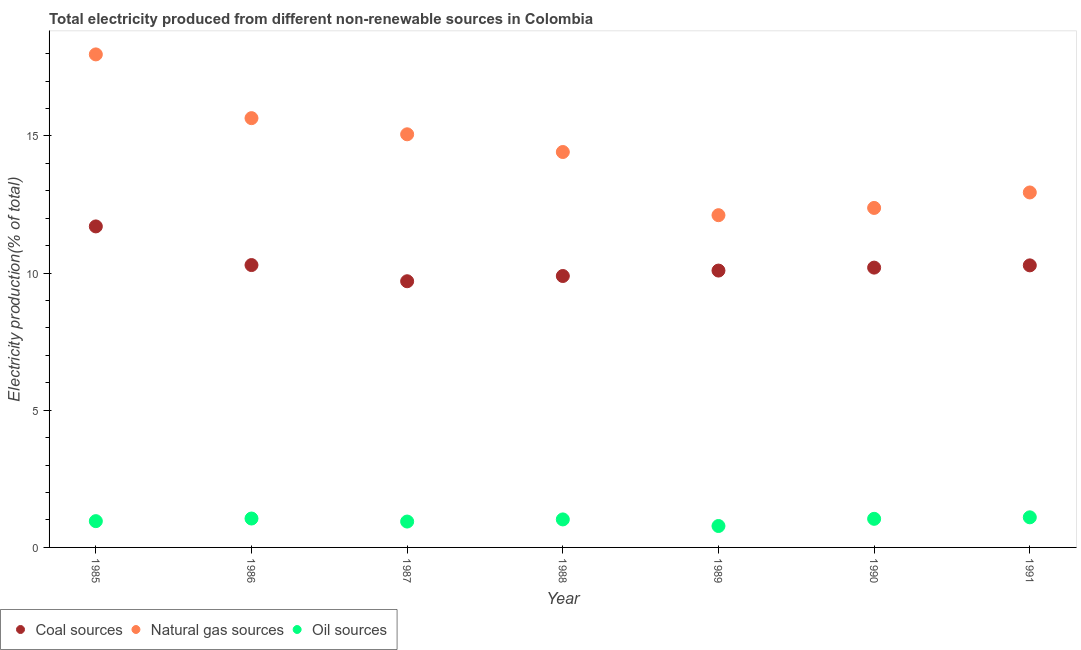Is the number of dotlines equal to the number of legend labels?
Offer a very short reply. Yes. What is the percentage of electricity produced by oil sources in 1988?
Make the answer very short. 1.02. Across all years, what is the maximum percentage of electricity produced by coal?
Ensure brevity in your answer.  11.7. Across all years, what is the minimum percentage of electricity produced by natural gas?
Your answer should be compact. 12.11. What is the total percentage of electricity produced by coal in the graph?
Your response must be concise. 72.16. What is the difference between the percentage of electricity produced by oil sources in 1986 and that in 1990?
Provide a succinct answer. 0.01. What is the difference between the percentage of electricity produced by oil sources in 1985 and the percentage of electricity produced by coal in 1990?
Keep it short and to the point. -9.24. What is the average percentage of electricity produced by natural gas per year?
Keep it short and to the point. 14.36. In the year 1986, what is the difference between the percentage of electricity produced by coal and percentage of electricity produced by oil sources?
Ensure brevity in your answer.  9.24. In how many years, is the percentage of electricity produced by natural gas greater than 13 %?
Your answer should be very brief. 4. What is the ratio of the percentage of electricity produced by oil sources in 1987 to that in 1991?
Ensure brevity in your answer.  0.86. What is the difference between the highest and the second highest percentage of electricity produced by coal?
Your answer should be very brief. 1.41. What is the difference between the highest and the lowest percentage of electricity produced by oil sources?
Your response must be concise. 0.32. Is it the case that in every year, the sum of the percentage of electricity produced by coal and percentage of electricity produced by natural gas is greater than the percentage of electricity produced by oil sources?
Keep it short and to the point. Yes. Does the percentage of electricity produced by natural gas monotonically increase over the years?
Keep it short and to the point. No. Is the percentage of electricity produced by oil sources strictly less than the percentage of electricity produced by natural gas over the years?
Provide a succinct answer. Yes. How many dotlines are there?
Your answer should be compact. 3. What is the difference between two consecutive major ticks on the Y-axis?
Offer a very short reply. 5. Are the values on the major ticks of Y-axis written in scientific E-notation?
Ensure brevity in your answer.  No. Does the graph contain grids?
Offer a very short reply. No. Where does the legend appear in the graph?
Provide a short and direct response. Bottom left. How are the legend labels stacked?
Provide a short and direct response. Horizontal. What is the title of the graph?
Your answer should be compact. Total electricity produced from different non-renewable sources in Colombia. Does "Tertiary" appear as one of the legend labels in the graph?
Offer a terse response. No. What is the label or title of the Y-axis?
Ensure brevity in your answer.  Electricity production(% of total). What is the Electricity production(% of total) in Coal sources in 1985?
Offer a very short reply. 11.7. What is the Electricity production(% of total) in Natural gas sources in 1985?
Make the answer very short. 17.97. What is the Electricity production(% of total) of Oil sources in 1985?
Offer a terse response. 0.96. What is the Electricity production(% of total) of Coal sources in 1986?
Ensure brevity in your answer.  10.29. What is the Electricity production(% of total) in Natural gas sources in 1986?
Keep it short and to the point. 15.65. What is the Electricity production(% of total) of Oil sources in 1986?
Provide a succinct answer. 1.05. What is the Electricity production(% of total) in Coal sources in 1987?
Give a very brief answer. 9.7. What is the Electricity production(% of total) in Natural gas sources in 1987?
Give a very brief answer. 15.06. What is the Electricity production(% of total) of Oil sources in 1987?
Ensure brevity in your answer.  0.94. What is the Electricity production(% of total) in Coal sources in 1988?
Make the answer very short. 9.89. What is the Electricity production(% of total) in Natural gas sources in 1988?
Provide a short and direct response. 14.41. What is the Electricity production(% of total) of Oil sources in 1988?
Your answer should be compact. 1.02. What is the Electricity production(% of total) of Coal sources in 1989?
Keep it short and to the point. 10.09. What is the Electricity production(% of total) of Natural gas sources in 1989?
Make the answer very short. 12.11. What is the Electricity production(% of total) in Oil sources in 1989?
Provide a short and direct response. 0.78. What is the Electricity production(% of total) of Coal sources in 1990?
Offer a terse response. 10.2. What is the Electricity production(% of total) of Natural gas sources in 1990?
Your response must be concise. 12.37. What is the Electricity production(% of total) in Oil sources in 1990?
Offer a very short reply. 1.04. What is the Electricity production(% of total) of Coal sources in 1991?
Keep it short and to the point. 10.28. What is the Electricity production(% of total) in Natural gas sources in 1991?
Ensure brevity in your answer.  12.94. What is the Electricity production(% of total) of Oil sources in 1991?
Keep it short and to the point. 1.1. Across all years, what is the maximum Electricity production(% of total) of Coal sources?
Your response must be concise. 11.7. Across all years, what is the maximum Electricity production(% of total) in Natural gas sources?
Provide a succinct answer. 17.97. Across all years, what is the maximum Electricity production(% of total) of Oil sources?
Provide a succinct answer. 1.1. Across all years, what is the minimum Electricity production(% of total) in Coal sources?
Your answer should be compact. 9.7. Across all years, what is the minimum Electricity production(% of total) of Natural gas sources?
Offer a very short reply. 12.11. Across all years, what is the minimum Electricity production(% of total) of Oil sources?
Your answer should be compact. 0.78. What is the total Electricity production(% of total) in Coal sources in the graph?
Your response must be concise. 72.16. What is the total Electricity production(% of total) of Natural gas sources in the graph?
Your answer should be very brief. 100.51. What is the total Electricity production(% of total) of Oil sources in the graph?
Ensure brevity in your answer.  6.9. What is the difference between the Electricity production(% of total) in Coal sources in 1985 and that in 1986?
Provide a short and direct response. 1.41. What is the difference between the Electricity production(% of total) in Natural gas sources in 1985 and that in 1986?
Offer a terse response. 2.32. What is the difference between the Electricity production(% of total) of Oil sources in 1985 and that in 1986?
Keep it short and to the point. -0.1. What is the difference between the Electricity production(% of total) in Coal sources in 1985 and that in 1987?
Offer a terse response. 2. What is the difference between the Electricity production(% of total) in Natural gas sources in 1985 and that in 1987?
Your answer should be compact. 2.91. What is the difference between the Electricity production(% of total) of Oil sources in 1985 and that in 1987?
Your answer should be compact. 0.01. What is the difference between the Electricity production(% of total) in Coal sources in 1985 and that in 1988?
Provide a succinct answer. 1.81. What is the difference between the Electricity production(% of total) of Natural gas sources in 1985 and that in 1988?
Keep it short and to the point. 3.56. What is the difference between the Electricity production(% of total) in Oil sources in 1985 and that in 1988?
Ensure brevity in your answer.  -0.06. What is the difference between the Electricity production(% of total) in Coal sources in 1985 and that in 1989?
Your answer should be very brief. 1.61. What is the difference between the Electricity production(% of total) in Natural gas sources in 1985 and that in 1989?
Provide a short and direct response. 5.86. What is the difference between the Electricity production(% of total) in Oil sources in 1985 and that in 1989?
Make the answer very short. 0.18. What is the difference between the Electricity production(% of total) in Coal sources in 1985 and that in 1990?
Make the answer very short. 1.5. What is the difference between the Electricity production(% of total) of Natural gas sources in 1985 and that in 1990?
Keep it short and to the point. 5.6. What is the difference between the Electricity production(% of total) of Oil sources in 1985 and that in 1990?
Your answer should be compact. -0.08. What is the difference between the Electricity production(% of total) of Coal sources in 1985 and that in 1991?
Offer a terse response. 1.42. What is the difference between the Electricity production(% of total) of Natural gas sources in 1985 and that in 1991?
Keep it short and to the point. 5.03. What is the difference between the Electricity production(% of total) in Oil sources in 1985 and that in 1991?
Make the answer very short. -0.14. What is the difference between the Electricity production(% of total) of Coal sources in 1986 and that in 1987?
Your answer should be compact. 0.59. What is the difference between the Electricity production(% of total) of Natural gas sources in 1986 and that in 1987?
Give a very brief answer. 0.59. What is the difference between the Electricity production(% of total) of Oil sources in 1986 and that in 1987?
Your response must be concise. 0.11. What is the difference between the Electricity production(% of total) in Coal sources in 1986 and that in 1988?
Give a very brief answer. 0.4. What is the difference between the Electricity production(% of total) in Natural gas sources in 1986 and that in 1988?
Offer a terse response. 1.23. What is the difference between the Electricity production(% of total) in Oil sources in 1986 and that in 1988?
Provide a short and direct response. 0.03. What is the difference between the Electricity production(% of total) in Coal sources in 1986 and that in 1989?
Offer a terse response. 0.2. What is the difference between the Electricity production(% of total) in Natural gas sources in 1986 and that in 1989?
Ensure brevity in your answer.  3.54. What is the difference between the Electricity production(% of total) of Oil sources in 1986 and that in 1989?
Give a very brief answer. 0.27. What is the difference between the Electricity production(% of total) of Coal sources in 1986 and that in 1990?
Your answer should be compact. 0.09. What is the difference between the Electricity production(% of total) of Natural gas sources in 1986 and that in 1990?
Your response must be concise. 3.27. What is the difference between the Electricity production(% of total) of Oil sources in 1986 and that in 1990?
Ensure brevity in your answer.  0.01. What is the difference between the Electricity production(% of total) in Coal sources in 1986 and that in 1991?
Your answer should be very brief. 0.01. What is the difference between the Electricity production(% of total) of Natural gas sources in 1986 and that in 1991?
Your response must be concise. 2.71. What is the difference between the Electricity production(% of total) in Oil sources in 1986 and that in 1991?
Ensure brevity in your answer.  -0.04. What is the difference between the Electricity production(% of total) in Coal sources in 1987 and that in 1988?
Your answer should be very brief. -0.19. What is the difference between the Electricity production(% of total) of Natural gas sources in 1987 and that in 1988?
Provide a succinct answer. 0.65. What is the difference between the Electricity production(% of total) in Oil sources in 1987 and that in 1988?
Make the answer very short. -0.08. What is the difference between the Electricity production(% of total) in Coal sources in 1987 and that in 1989?
Give a very brief answer. -0.39. What is the difference between the Electricity production(% of total) in Natural gas sources in 1987 and that in 1989?
Your answer should be compact. 2.95. What is the difference between the Electricity production(% of total) of Oil sources in 1987 and that in 1989?
Keep it short and to the point. 0.16. What is the difference between the Electricity production(% of total) of Coal sources in 1987 and that in 1990?
Offer a terse response. -0.5. What is the difference between the Electricity production(% of total) in Natural gas sources in 1987 and that in 1990?
Offer a very short reply. 2.68. What is the difference between the Electricity production(% of total) of Oil sources in 1987 and that in 1990?
Your answer should be compact. -0.1. What is the difference between the Electricity production(% of total) of Coal sources in 1987 and that in 1991?
Keep it short and to the point. -0.58. What is the difference between the Electricity production(% of total) of Natural gas sources in 1987 and that in 1991?
Provide a short and direct response. 2.12. What is the difference between the Electricity production(% of total) in Oil sources in 1987 and that in 1991?
Your answer should be very brief. -0.15. What is the difference between the Electricity production(% of total) in Coal sources in 1988 and that in 1989?
Offer a terse response. -0.2. What is the difference between the Electricity production(% of total) of Natural gas sources in 1988 and that in 1989?
Ensure brevity in your answer.  2.3. What is the difference between the Electricity production(% of total) of Oil sources in 1988 and that in 1989?
Offer a terse response. 0.24. What is the difference between the Electricity production(% of total) of Coal sources in 1988 and that in 1990?
Offer a terse response. -0.31. What is the difference between the Electricity production(% of total) of Natural gas sources in 1988 and that in 1990?
Your answer should be compact. 2.04. What is the difference between the Electricity production(% of total) of Oil sources in 1988 and that in 1990?
Your answer should be very brief. -0.02. What is the difference between the Electricity production(% of total) in Coal sources in 1988 and that in 1991?
Your response must be concise. -0.39. What is the difference between the Electricity production(% of total) in Natural gas sources in 1988 and that in 1991?
Offer a very short reply. 1.47. What is the difference between the Electricity production(% of total) in Oil sources in 1988 and that in 1991?
Your answer should be compact. -0.08. What is the difference between the Electricity production(% of total) in Coal sources in 1989 and that in 1990?
Ensure brevity in your answer.  -0.11. What is the difference between the Electricity production(% of total) in Natural gas sources in 1989 and that in 1990?
Your answer should be very brief. -0.26. What is the difference between the Electricity production(% of total) in Oil sources in 1989 and that in 1990?
Your answer should be very brief. -0.26. What is the difference between the Electricity production(% of total) in Coal sources in 1989 and that in 1991?
Keep it short and to the point. -0.19. What is the difference between the Electricity production(% of total) of Natural gas sources in 1989 and that in 1991?
Keep it short and to the point. -0.83. What is the difference between the Electricity production(% of total) in Oil sources in 1989 and that in 1991?
Your answer should be compact. -0.32. What is the difference between the Electricity production(% of total) in Coal sources in 1990 and that in 1991?
Your answer should be very brief. -0.08. What is the difference between the Electricity production(% of total) of Natural gas sources in 1990 and that in 1991?
Make the answer very short. -0.56. What is the difference between the Electricity production(% of total) in Oil sources in 1990 and that in 1991?
Ensure brevity in your answer.  -0.06. What is the difference between the Electricity production(% of total) of Coal sources in 1985 and the Electricity production(% of total) of Natural gas sources in 1986?
Your answer should be very brief. -3.95. What is the difference between the Electricity production(% of total) in Coal sources in 1985 and the Electricity production(% of total) in Oil sources in 1986?
Provide a succinct answer. 10.65. What is the difference between the Electricity production(% of total) of Natural gas sources in 1985 and the Electricity production(% of total) of Oil sources in 1986?
Provide a succinct answer. 16.92. What is the difference between the Electricity production(% of total) in Coal sources in 1985 and the Electricity production(% of total) in Natural gas sources in 1987?
Offer a terse response. -3.36. What is the difference between the Electricity production(% of total) of Coal sources in 1985 and the Electricity production(% of total) of Oil sources in 1987?
Provide a short and direct response. 10.76. What is the difference between the Electricity production(% of total) in Natural gas sources in 1985 and the Electricity production(% of total) in Oil sources in 1987?
Keep it short and to the point. 17.03. What is the difference between the Electricity production(% of total) in Coal sources in 1985 and the Electricity production(% of total) in Natural gas sources in 1988?
Your answer should be compact. -2.71. What is the difference between the Electricity production(% of total) of Coal sources in 1985 and the Electricity production(% of total) of Oil sources in 1988?
Provide a succinct answer. 10.68. What is the difference between the Electricity production(% of total) in Natural gas sources in 1985 and the Electricity production(% of total) in Oil sources in 1988?
Ensure brevity in your answer.  16.95. What is the difference between the Electricity production(% of total) in Coal sources in 1985 and the Electricity production(% of total) in Natural gas sources in 1989?
Provide a succinct answer. -0.41. What is the difference between the Electricity production(% of total) in Coal sources in 1985 and the Electricity production(% of total) in Oil sources in 1989?
Your answer should be compact. 10.92. What is the difference between the Electricity production(% of total) in Natural gas sources in 1985 and the Electricity production(% of total) in Oil sources in 1989?
Offer a very short reply. 17.19. What is the difference between the Electricity production(% of total) of Coal sources in 1985 and the Electricity production(% of total) of Natural gas sources in 1990?
Give a very brief answer. -0.67. What is the difference between the Electricity production(% of total) in Coal sources in 1985 and the Electricity production(% of total) in Oil sources in 1990?
Offer a terse response. 10.66. What is the difference between the Electricity production(% of total) in Natural gas sources in 1985 and the Electricity production(% of total) in Oil sources in 1990?
Provide a succinct answer. 16.93. What is the difference between the Electricity production(% of total) of Coal sources in 1985 and the Electricity production(% of total) of Natural gas sources in 1991?
Offer a terse response. -1.24. What is the difference between the Electricity production(% of total) in Coal sources in 1985 and the Electricity production(% of total) in Oil sources in 1991?
Give a very brief answer. 10.6. What is the difference between the Electricity production(% of total) of Natural gas sources in 1985 and the Electricity production(% of total) of Oil sources in 1991?
Your answer should be very brief. 16.87. What is the difference between the Electricity production(% of total) of Coal sources in 1986 and the Electricity production(% of total) of Natural gas sources in 1987?
Your answer should be very brief. -4.77. What is the difference between the Electricity production(% of total) in Coal sources in 1986 and the Electricity production(% of total) in Oil sources in 1987?
Your answer should be very brief. 9.35. What is the difference between the Electricity production(% of total) in Natural gas sources in 1986 and the Electricity production(% of total) in Oil sources in 1987?
Provide a succinct answer. 14.7. What is the difference between the Electricity production(% of total) in Coal sources in 1986 and the Electricity production(% of total) in Natural gas sources in 1988?
Offer a terse response. -4.12. What is the difference between the Electricity production(% of total) of Coal sources in 1986 and the Electricity production(% of total) of Oil sources in 1988?
Make the answer very short. 9.27. What is the difference between the Electricity production(% of total) of Natural gas sources in 1986 and the Electricity production(% of total) of Oil sources in 1988?
Your response must be concise. 14.63. What is the difference between the Electricity production(% of total) in Coal sources in 1986 and the Electricity production(% of total) in Natural gas sources in 1989?
Provide a short and direct response. -1.82. What is the difference between the Electricity production(% of total) in Coal sources in 1986 and the Electricity production(% of total) in Oil sources in 1989?
Give a very brief answer. 9.51. What is the difference between the Electricity production(% of total) in Natural gas sources in 1986 and the Electricity production(% of total) in Oil sources in 1989?
Provide a succinct answer. 14.87. What is the difference between the Electricity production(% of total) in Coal sources in 1986 and the Electricity production(% of total) in Natural gas sources in 1990?
Offer a very short reply. -2.08. What is the difference between the Electricity production(% of total) of Coal sources in 1986 and the Electricity production(% of total) of Oil sources in 1990?
Give a very brief answer. 9.25. What is the difference between the Electricity production(% of total) in Natural gas sources in 1986 and the Electricity production(% of total) in Oil sources in 1990?
Provide a short and direct response. 14.6. What is the difference between the Electricity production(% of total) in Coal sources in 1986 and the Electricity production(% of total) in Natural gas sources in 1991?
Keep it short and to the point. -2.65. What is the difference between the Electricity production(% of total) of Coal sources in 1986 and the Electricity production(% of total) of Oil sources in 1991?
Offer a very short reply. 9.19. What is the difference between the Electricity production(% of total) in Natural gas sources in 1986 and the Electricity production(% of total) in Oil sources in 1991?
Make the answer very short. 14.55. What is the difference between the Electricity production(% of total) in Coal sources in 1987 and the Electricity production(% of total) in Natural gas sources in 1988?
Ensure brevity in your answer.  -4.71. What is the difference between the Electricity production(% of total) of Coal sources in 1987 and the Electricity production(% of total) of Oil sources in 1988?
Offer a very short reply. 8.68. What is the difference between the Electricity production(% of total) in Natural gas sources in 1987 and the Electricity production(% of total) in Oil sources in 1988?
Offer a very short reply. 14.04. What is the difference between the Electricity production(% of total) in Coal sources in 1987 and the Electricity production(% of total) in Natural gas sources in 1989?
Your answer should be very brief. -2.41. What is the difference between the Electricity production(% of total) of Coal sources in 1987 and the Electricity production(% of total) of Oil sources in 1989?
Provide a succinct answer. 8.92. What is the difference between the Electricity production(% of total) of Natural gas sources in 1987 and the Electricity production(% of total) of Oil sources in 1989?
Provide a short and direct response. 14.28. What is the difference between the Electricity production(% of total) in Coal sources in 1987 and the Electricity production(% of total) in Natural gas sources in 1990?
Keep it short and to the point. -2.67. What is the difference between the Electricity production(% of total) in Coal sources in 1987 and the Electricity production(% of total) in Oil sources in 1990?
Your answer should be compact. 8.66. What is the difference between the Electricity production(% of total) of Natural gas sources in 1987 and the Electricity production(% of total) of Oil sources in 1990?
Your response must be concise. 14.02. What is the difference between the Electricity production(% of total) of Coal sources in 1987 and the Electricity production(% of total) of Natural gas sources in 1991?
Provide a succinct answer. -3.24. What is the difference between the Electricity production(% of total) in Coal sources in 1987 and the Electricity production(% of total) in Oil sources in 1991?
Ensure brevity in your answer.  8.6. What is the difference between the Electricity production(% of total) in Natural gas sources in 1987 and the Electricity production(% of total) in Oil sources in 1991?
Offer a terse response. 13.96. What is the difference between the Electricity production(% of total) of Coal sources in 1988 and the Electricity production(% of total) of Natural gas sources in 1989?
Your answer should be very brief. -2.22. What is the difference between the Electricity production(% of total) of Coal sources in 1988 and the Electricity production(% of total) of Oil sources in 1989?
Keep it short and to the point. 9.11. What is the difference between the Electricity production(% of total) of Natural gas sources in 1988 and the Electricity production(% of total) of Oil sources in 1989?
Keep it short and to the point. 13.63. What is the difference between the Electricity production(% of total) in Coal sources in 1988 and the Electricity production(% of total) in Natural gas sources in 1990?
Your answer should be compact. -2.48. What is the difference between the Electricity production(% of total) of Coal sources in 1988 and the Electricity production(% of total) of Oil sources in 1990?
Your answer should be compact. 8.85. What is the difference between the Electricity production(% of total) in Natural gas sources in 1988 and the Electricity production(% of total) in Oil sources in 1990?
Your answer should be very brief. 13.37. What is the difference between the Electricity production(% of total) of Coal sources in 1988 and the Electricity production(% of total) of Natural gas sources in 1991?
Give a very brief answer. -3.05. What is the difference between the Electricity production(% of total) in Coal sources in 1988 and the Electricity production(% of total) in Oil sources in 1991?
Provide a succinct answer. 8.8. What is the difference between the Electricity production(% of total) of Natural gas sources in 1988 and the Electricity production(% of total) of Oil sources in 1991?
Keep it short and to the point. 13.32. What is the difference between the Electricity production(% of total) in Coal sources in 1989 and the Electricity production(% of total) in Natural gas sources in 1990?
Ensure brevity in your answer.  -2.28. What is the difference between the Electricity production(% of total) of Coal sources in 1989 and the Electricity production(% of total) of Oil sources in 1990?
Your answer should be compact. 9.05. What is the difference between the Electricity production(% of total) of Natural gas sources in 1989 and the Electricity production(% of total) of Oil sources in 1990?
Ensure brevity in your answer.  11.07. What is the difference between the Electricity production(% of total) in Coal sources in 1989 and the Electricity production(% of total) in Natural gas sources in 1991?
Your response must be concise. -2.85. What is the difference between the Electricity production(% of total) of Coal sources in 1989 and the Electricity production(% of total) of Oil sources in 1991?
Your answer should be very brief. 8.99. What is the difference between the Electricity production(% of total) of Natural gas sources in 1989 and the Electricity production(% of total) of Oil sources in 1991?
Give a very brief answer. 11.01. What is the difference between the Electricity production(% of total) of Coal sources in 1990 and the Electricity production(% of total) of Natural gas sources in 1991?
Provide a short and direct response. -2.74. What is the difference between the Electricity production(% of total) in Coal sources in 1990 and the Electricity production(% of total) in Oil sources in 1991?
Offer a terse response. 9.1. What is the difference between the Electricity production(% of total) in Natural gas sources in 1990 and the Electricity production(% of total) in Oil sources in 1991?
Make the answer very short. 11.28. What is the average Electricity production(% of total) of Coal sources per year?
Your answer should be compact. 10.31. What is the average Electricity production(% of total) in Natural gas sources per year?
Your answer should be very brief. 14.36. What is the average Electricity production(% of total) of Oil sources per year?
Provide a succinct answer. 0.99. In the year 1985, what is the difference between the Electricity production(% of total) of Coal sources and Electricity production(% of total) of Natural gas sources?
Keep it short and to the point. -6.27. In the year 1985, what is the difference between the Electricity production(% of total) of Coal sources and Electricity production(% of total) of Oil sources?
Your response must be concise. 10.74. In the year 1985, what is the difference between the Electricity production(% of total) of Natural gas sources and Electricity production(% of total) of Oil sources?
Provide a short and direct response. 17.01. In the year 1986, what is the difference between the Electricity production(% of total) in Coal sources and Electricity production(% of total) in Natural gas sources?
Provide a short and direct response. -5.36. In the year 1986, what is the difference between the Electricity production(% of total) in Coal sources and Electricity production(% of total) in Oil sources?
Keep it short and to the point. 9.24. In the year 1986, what is the difference between the Electricity production(% of total) in Natural gas sources and Electricity production(% of total) in Oil sources?
Offer a terse response. 14.59. In the year 1987, what is the difference between the Electricity production(% of total) of Coal sources and Electricity production(% of total) of Natural gas sources?
Keep it short and to the point. -5.36. In the year 1987, what is the difference between the Electricity production(% of total) of Coal sources and Electricity production(% of total) of Oil sources?
Provide a short and direct response. 8.76. In the year 1987, what is the difference between the Electricity production(% of total) of Natural gas sources and Electricity production(% of total) of Oil sources?
Make the answer very short. 14.12. In the year 1988, what is the difference between the Electricity production(% of total) of Coal sources and Electricity production(% of total) of Natural gas sources?
Your response must be concise. -4.52. In the year 1988, what is the difference between the Electricity production(% of total) in Coal sources and Electricity production(% of total) in Oil sources?
Your answer should be very brief. 8.87. In the year 1988, what is the difference between the Electricity production(% of total) in Natural gas sources and Electricity production(% of total) in Oil sources?
Your answer should be very brief. 13.39. In the year 1989, what is the difference between the Electricity production(% of total) in Coal sources and Electricity production(% of total) in Natural gas sources?
Make the answer very short. -2.02. In the year 1989, what is the difference between the Electricity production(% of total) of Coal sources and Electricity production(% of total) of Oil sources?
Ensure brevity in your answer.  9.31. In the year 1989, what is the difference between the Electricity production(% of total) of Natural gas sources and Electricity production(% of total) of Oil sources?
Offer a terse response. 11.33. In the year 1990, what is the difference between the Electricity production(% of total) of Coal sources and Electricity production(% of total) of Natural gas sources?
Offer a very short reply. -2.18. In the year 1990, what is the difference between the Electricity production(% of total) of Coal sources and Electricity production(% of total) of Oil sources?
Your answer should be compact. 9.16. In the year 1990, what is the difference between the Electricity production(% of total) in Natural gas sources and Electricity production(% of total) in Oil sources?
Offer a very short reply. 11.33. In the year 1991, what is the difference between the Electricity production(% of total) of Coal sources and Electricity production(% of total) of Natural gas sources?
Offer a terse response. -2.66. In the year 1991, what is the difference between the Electricity production(% of total) of Coal sources and Electricity production(% of total) of Oil sources?
Offer a very short reply. 9.18. In the year 1991, what is the difference between the Electricity production(% of total) of Natural gas sources and Electricity production(% of total) of Oil sources?
Provide a succinct answer. 11.84. What is the ratio of the Electricity production(% of total) of Coal sources in 1985 to that in 1986?
Ensure brevity in your answer.  1.14. What is the ratio of the Electricity production(% of total) of Natural gas sources in 1985 to that in 1986?
Provide a short and direct response. 1.15. What is the ratio of the Electricity production(% of total) of Oil sources in 1985 to that in 1986?
Give a very brief answer. 0.91. What is the ratio of the Electricity production(% of total) in Coal sources in 1985 to that in 1987?
Give a very brief answer. 1.21. What is the ratio of the Electricity production(% of total) of Natural gas sources in 1985 to that in 1987?
Provide a succinct answer. 1.19. What is the ratio of the Electricity production(% of total) in Oil sources in 1985 to that in 1987?
Provide a short and direct response. 1.02. What is the ratio of the Electricity production(% of total) of Coal sources in 1985 to that in 1988?
Provide a short and direct response. 1.18. What is the ratio of the Electricity production(% of total) in Natural gas sources in 1985 to that in 1988?
Provide a succinct answer. 1.25. What is the ratio of the Electricity production(% of total) of Oil sources in 1985 to that in 1988?
Your response must be concise. 0.94. What is the ratio of the Electricity production(% of total) in Coal sources in 1985 to that in 1989?
Provide a short and direct response. 1.16. What is the ratio of the Electricity production(% of total) of Natural gas sources in 1985 to that in 1989?
Your response must be concise. 1.48. What is the ratio of the Electricity production(% of total) of Oil sources in 1985 to that in 1989?
Ensure brevity in your answer.  1.23. What is the ratio of the Electricity production(% of total) of Coal sources in 1985 to that in 1990?
Make the answer very short. 1.15. What is the ratio of the Electricity production(% of total) in Natural gas sources in 1985 to that in 1990?
Make the answer very short. 1.45. What is the ratio of the Electricity production(% of total) of Oil sources in 1985 to that in 1990?
Your answer should be very brief. 0.92. What is the ratio of the Electricity production(% of total) of Coal sources in 1985 to that in 1991?
Offer a terse response. 1.14. What is the ratio of the Electricity production(% of total) of Natural gas sources in 1985 to that in 1991?
Offer a very short reply. 1.39. What is the ratio of the Electricity production(% of total) in Oil sources in 1985 to that in 1991?
Ensure brevity in your answer.  0.87. What is the ratio of the Electricity production(% of total) of Coal sources in 1986 to that in 1987?
Offer a terse response. 1.06. What is the ratio of the Electricity production(% of total) of Natural gas sources in 1986 to that in 1987?
Ensure brevity in your answer.  1.04. What is the ratio of the Electricity production(% of total) in Oil sources in 1986 to that in 1987?
Keep it short and to the point. 1.12. What is the ratio of the Electricity production(% of total) in Coal sources in 1986 to that in 1988?
Your response must be concise. 1.04. What is the ratio of the Electricity production(% of total) of Natural gas sources in 1986 to that in 1988?
Offer a terse response. 1.09. What is the ratio of the Electricity production(% of total) of Oil sources in 1986 to that in 1988?
Provide a succinct answer. 1.03. What is the ratio of the Electricity production(% of total) in Coal sources in 1986 to that in 1989?
Offer a very short reply. 1.02. What is the ratio of the Electricity production(% of total) of Natural gas sources in 1986 to that in 1989?
Offer a very short reply. 1.29. What is the ratio of the Electricity production(% of total) of Oil sources in 1986 to that in 1989?
Ensure brevity in your answer.  1.35. What is the ratio of the Electricity production(% of total) in Coal sources in 1986 to that in 1990?
Your answer should be compact. 1.01. What is the ratio of the Electricity production(% of total) in Natural gas sources in 1986 to that in 1990?
Offer a terse response. 1.26. What is the ratio of the Electricity production(% of total) in Oil sources in 1986 to that in 1990?
Give a very brief answer. 1.01. What is the ratio of the Electricity production(% of total) of Coal sources in 1986 to that in 1991?
Your response must be concise. 1. What is the ratio of the Electricity production(% of total) in Natural gas sources in 1986 to that in 1991?
Give a very brief answer. 1.21. What is the ratio of the Electricity production(% of total) in Oil sources in 1986 to that in 1991?
Ensure brevity in your answer.  0.96. What is the ratio of the Electricity production(% of total) of Coal sources in 1987 to that in 1988?
Make the answer very short. 0.98. What is the ratio of the Electricity production(% of total) of Natural gas sources in 1987 to that in 1988?
Your answer should be very brief. 1.04. What is the ratio of the Electricity production(% of total) in Oil sources in 1987 to that in 1988?
Make the answer very short. 0.92. What is the ratio of the Electricity production(% of total) of Coal sources in 1987 to that in 1989?
Your answer should be very brief. 0.96. What is the ratio of the Electricity production(% of total) in Natural gas sources in 1987 to that in 1989?
Ensure brevity in your answer.  1.24. What is the ratio of the Electricity production(% of total) of Oil sources in 1987 to that in 1989?
Provide a succinct answer. 1.21. What is the ratio of the Electricity production(% of total) in Coal sources in 1987 to that in 1990?
Keep it short and to the point. 0.95. What is the ratio of the Electricity production(% of total) in Natural gas sources in 1987 to that in 1990?
Your response must be concise. 1.22. What is the ratio of the Electricity production(% of total) in Oil sources in 1987 to that in 1990?
Provide a succinct answer. 0.9. What is the ratio of the Electricity production(% of total) in Coal sources in 1987 to that in 1991?
Keep it short and to the point. 0.94. What is the ratio of the Electricity production(% of total) in Natural gas sources in 1987 to that in 1991?
Your answer should be compact. 1.16. What is the ratio of the Electricity production(% of total) of Oil sources in 1987 to that in 1991?
Your response must be concise. 0.86. What is the ratio of the Electricity production(% of total) in Coal sources in 1988 to that in 1989?
Provide a succinct answer. 0.98. What is the ratio of the Electricity production(% of total) in Natural gas sources in 1988 to that in 1989?
Provide a short and direct response. 1.19. What is the ratio of the Electricity production(% of total) in Oil sources in 1988 to that in 1989?
Your response must be concise. 1.31. What is the ratio of the Electricity production(% of total) in Coal sources in 1988 to that in 1990?
Ensure brevity in your answer.  0.97. What is the ratio of the Electricity production(% of total) of Natural gas sources in 1988 to that in 1990?
Give a very brief answer. 1.16. What is the ratio of the Electricity production(% of total) in Oil sources in 1988 to that in 1990?
Provide a short and direct response. 0.98. What is the ratio of the Electricity production(% of total) of Coal sources in 1988 to that in 1991?
Provide a succinct answer. 0.96. What is the ratio of the Electricity production(% of total) of Natural gas sources in 1988 to that in 1991?
Provide a succinct answer. 1.11. What is the ratio of the Electricity production(% of total) of Oil sources in 1988 to that in 1991?
Provide a short and direct response. 0.93. What is the ratio of the Electricity production(% of total) of Natural gas sources in 1989 to that in 1990?
Your answer should be compact. 0.98. What is the ratio of the Electricity production(% of total) of Oil sources in 1989 to that in 1990?
Offer a very short reply. 0.75. What is the ratio of the Electricity production(% of total) in Coal sources in 1989 to that in 1991?
Make the answer very short. 0.98. What is the ratio of the Electricity production(% of total) in Natural gas sources in 1989 to that in 1991?
Your answer should be very brief. 0.94. What is the ratio of the Electricity production(% of total) in Oil sources in 1989 to that in 1991?
Your response must be concise. 0.71. What is the ratio of the Electricity production(% of total) in Natural gas sources in 1990 to that in 1991?
Your answer should be very brief. 0.96. What is the ratio of the Electricity production(% of total) in Oil sources in 1990 to that in 1991?
Keep it short and to the point. 0.95. What is the difference between the highest and the second highest Electricity production(% of total) in Coal sources?
Your answer should be very brief. 1.41. What is the difference between the highest and the second highest Electricity production(% of total) in Natural gas sources?
Ensure brevity in your answer.  2.32. What is the difference between the highest and the second highest Electricity production(% of total) of Oil sources?
Keep it short and to the point. 0.04. What is the difference between the highest and the lowest Electricity production(% of total) in Coal sources?
Your response must be concise. 2. What is the difference between the highest and the lowest Electricity production(% of total) in Natural gas sources?
Provide a short and direct response. 5.86. What is the difference between the highest and the lowest Electricity production(% of total) in Oil sources?
Provide a short and direct response. 0.32. 